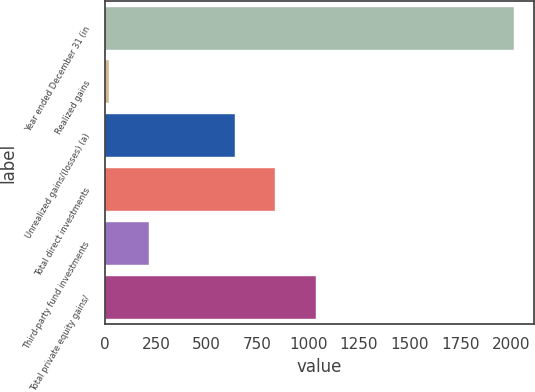<chart> <loc_0><loc_0><loc_500><loc_500><bar_chart><fcel>Year ended December 31 (in<fcel>Realized gains<fcel>Unrealized gains/(losses) (a)<fcel>Total direct investments<fcel>Third-party fund investments<fcel>Total private equity gains/<nl><fcel>2012<fcel>17<fcel>639<fcel>838.5<fcel>216.5<fcel>1038<nl></chart> 